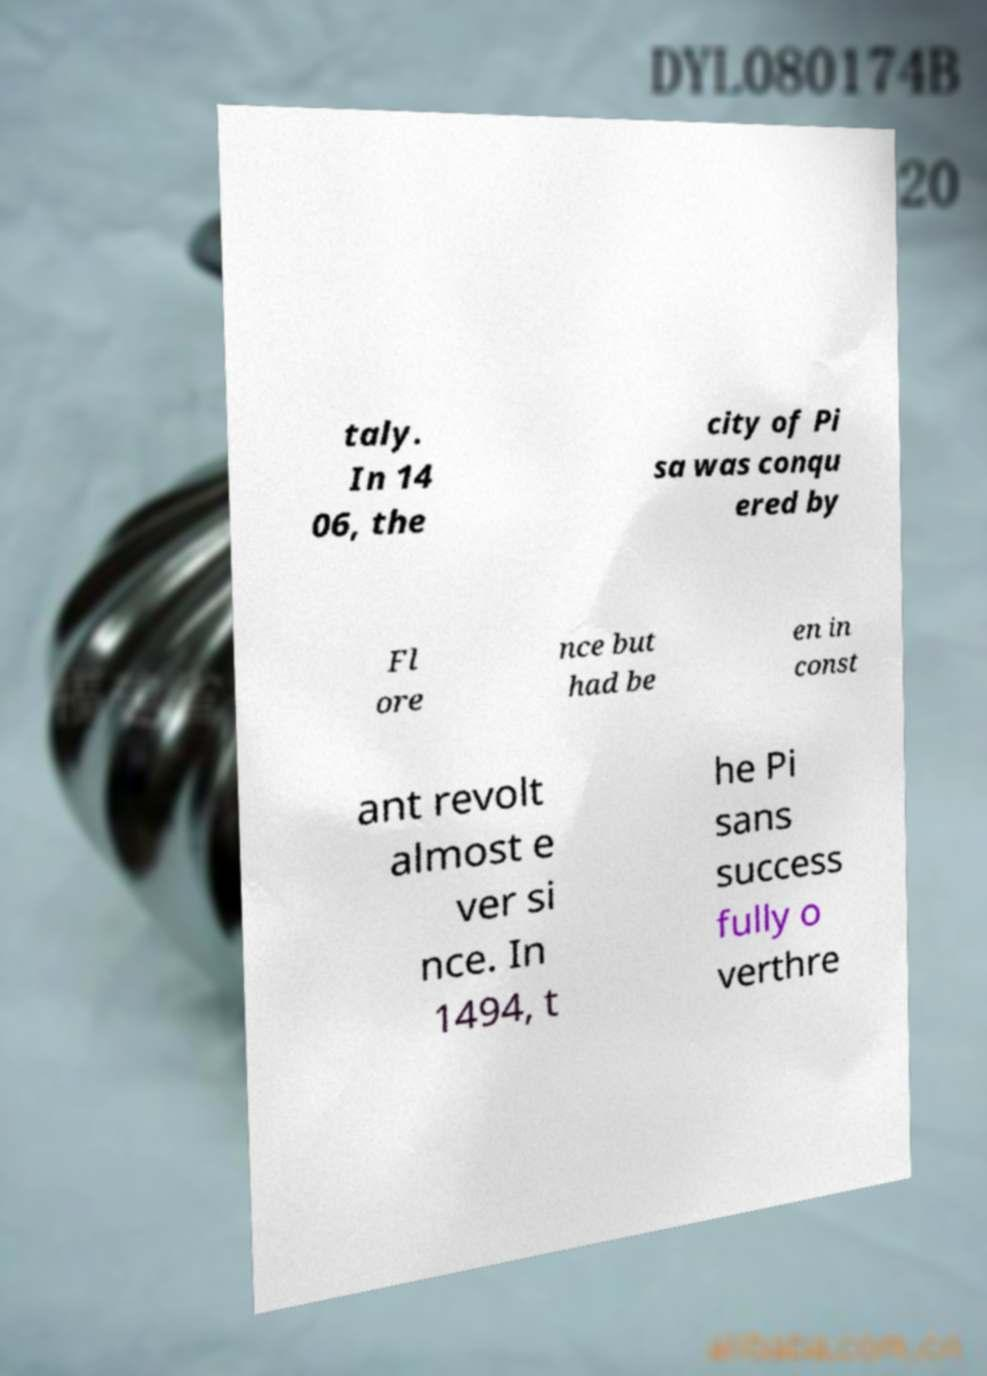For documentation purposes, I need the text within this image transcribed. Could you provide that? taly. In 14 06, the city of Pi sa was conqu ered by Fl ore nce but had be en in const ant revolt almost e ver si nce. In 1494, t he Pi sans success fully o verthre 